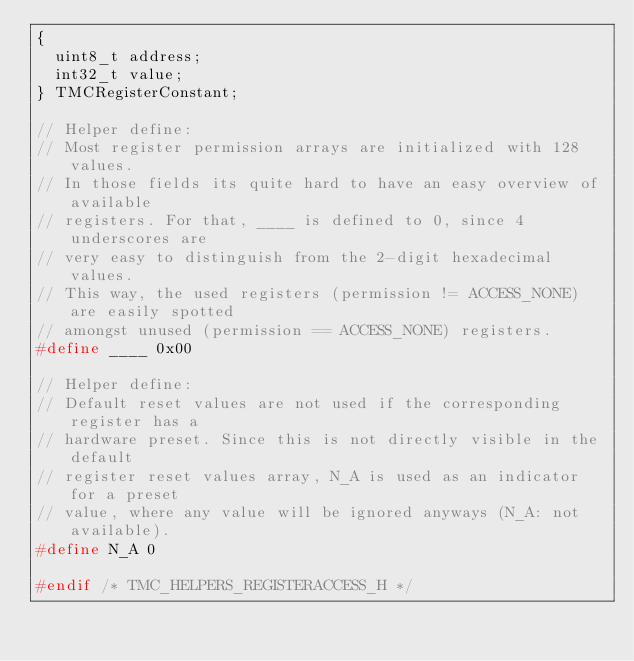<code> <loc_0><loc_0><loc_500><loc_500><_C_>{
	uint8_t address;
	int32_t value;
} TMCRegisterConstant;

// Helper define:
// Most register permission arrays are initialized with 128 values.
// In those fields its quite hard to have an easy overview of available
// registers. For that, ____ is defined to 0, since 4 underscores are
// very easy to distinguish from the 2-digit hexadecimal values.
// This way, the used registers (permission != ACCESS_NONE) are easily spotted
// amongst unused (permission == ACCESS_NONE) registers.
#define ____ 0x00

// Helper define:
// Default reset values are not used if the corresponding register has a
// hardware preset. Since this is not directly visible in the default
// register reset values array, N_A is used as an indicator for a preset
// value, where any value will be ignored anyways (N_A: not available).
#define N_A 0

#endif /* TMC_HELPERS_REGISTERACCESS_H */
</code> 